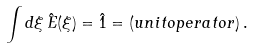Convert formula to latex. <formula><loc_0><loc_0><loc_500><loc_500>\int d \xi \, \hat { E } ( \xi ) = \hat { 1 } = ( u n i t o p e r a t o r ) \, .</formula> 